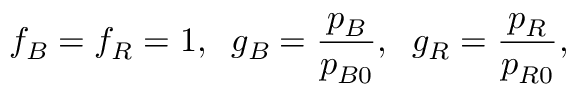Convert formula to latex. <formula><loc_0><loc_0><loc_500><loc_500>f _ { B } = f _ { R } = 1 , \, g _ { B } = \frac { p _ { B } } { p _ { B 0 } } , \, g _ { R } = \frac { p _ { R } } { p _ { R 0 } } ,</formula> 